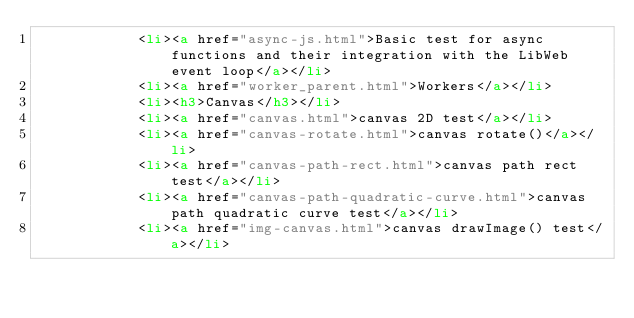Convert code to text. <code><loc_0><loc_0><loc_500><loc_500><_HTML_>            <li><a href="async-js.html">Basic test for async functions and their integration with the LibWeb event loop</a></li>
            <li><a href="worker_parent.html">Workers</a></li>
            <li><h3>Canvas</h3></li>
            <li><a href="canvas.html">canvas 2D test</a></li>
            <li><a href="canvas-rotate.html">canvas rotate()</a></li>
            <li><a href="canvas-path-rect.html">canvas path rect test</a></li>
            <li><a href="canvas-path-quadratic-curve.html">canvas path quadratic curve test</a></li>
            <li><a href="img-canvas.html">canvas drawImage() test</a></li></code> 